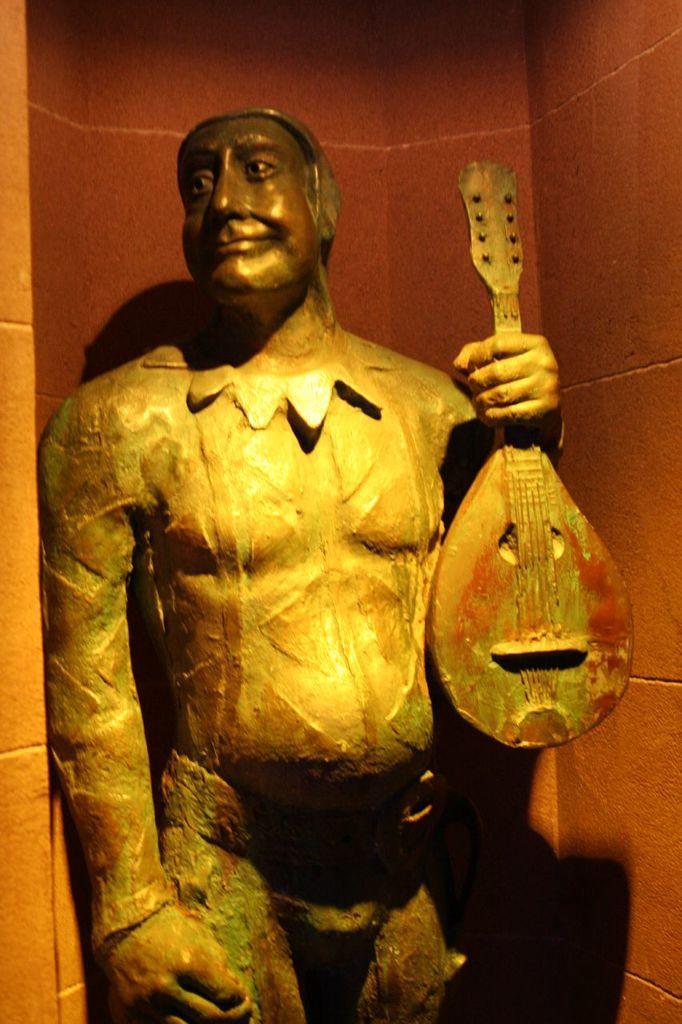Could you give a brief overview of what you see in this image? This image consists of an idol of a man. He is holding a guitar. In the background, we can see a wall. 